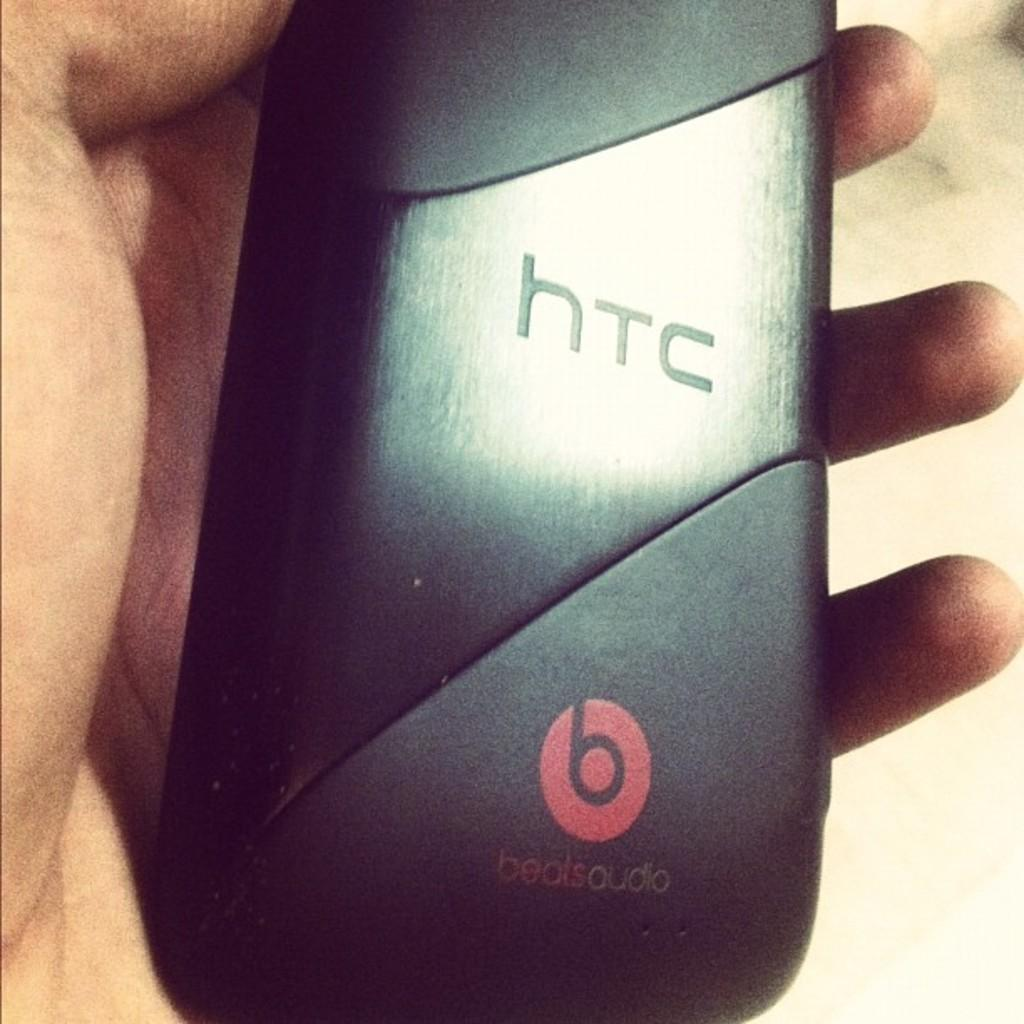<image>
Present a compact description of the photo's key features. A man is holding a phone with the back facing to the camera showing that its an HTC phone. 